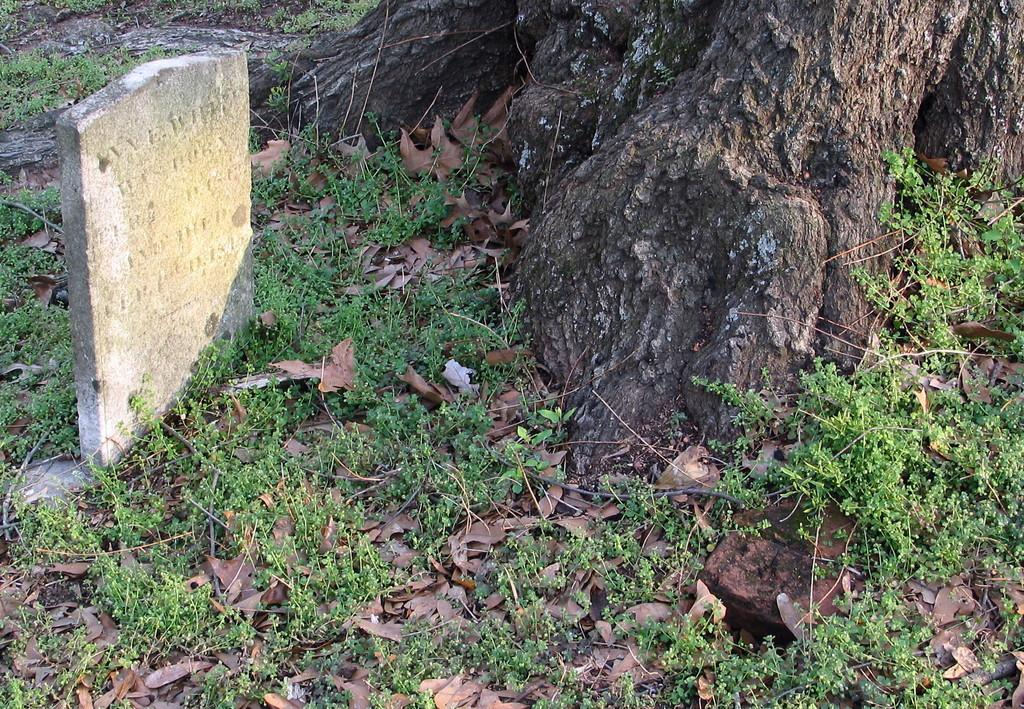What is located at the bottom of the picture? There are herbs, dry leaves, and twigs visible at the bottom of the picture. What can be seen on the left side of the picture? There is a gravestone on the left side of the picture. What part of a tree is visible at the top of the picture? The stem of a tree is visible at the top of the picture. What type of pie is being served at the gravestone in the image? There is no pie present in the image; it features herbs, dry leaves, twigs, a gravestone, and a tree stem. What fact can be learned about the pear tree in the image? There is no pear tree present in the image. 